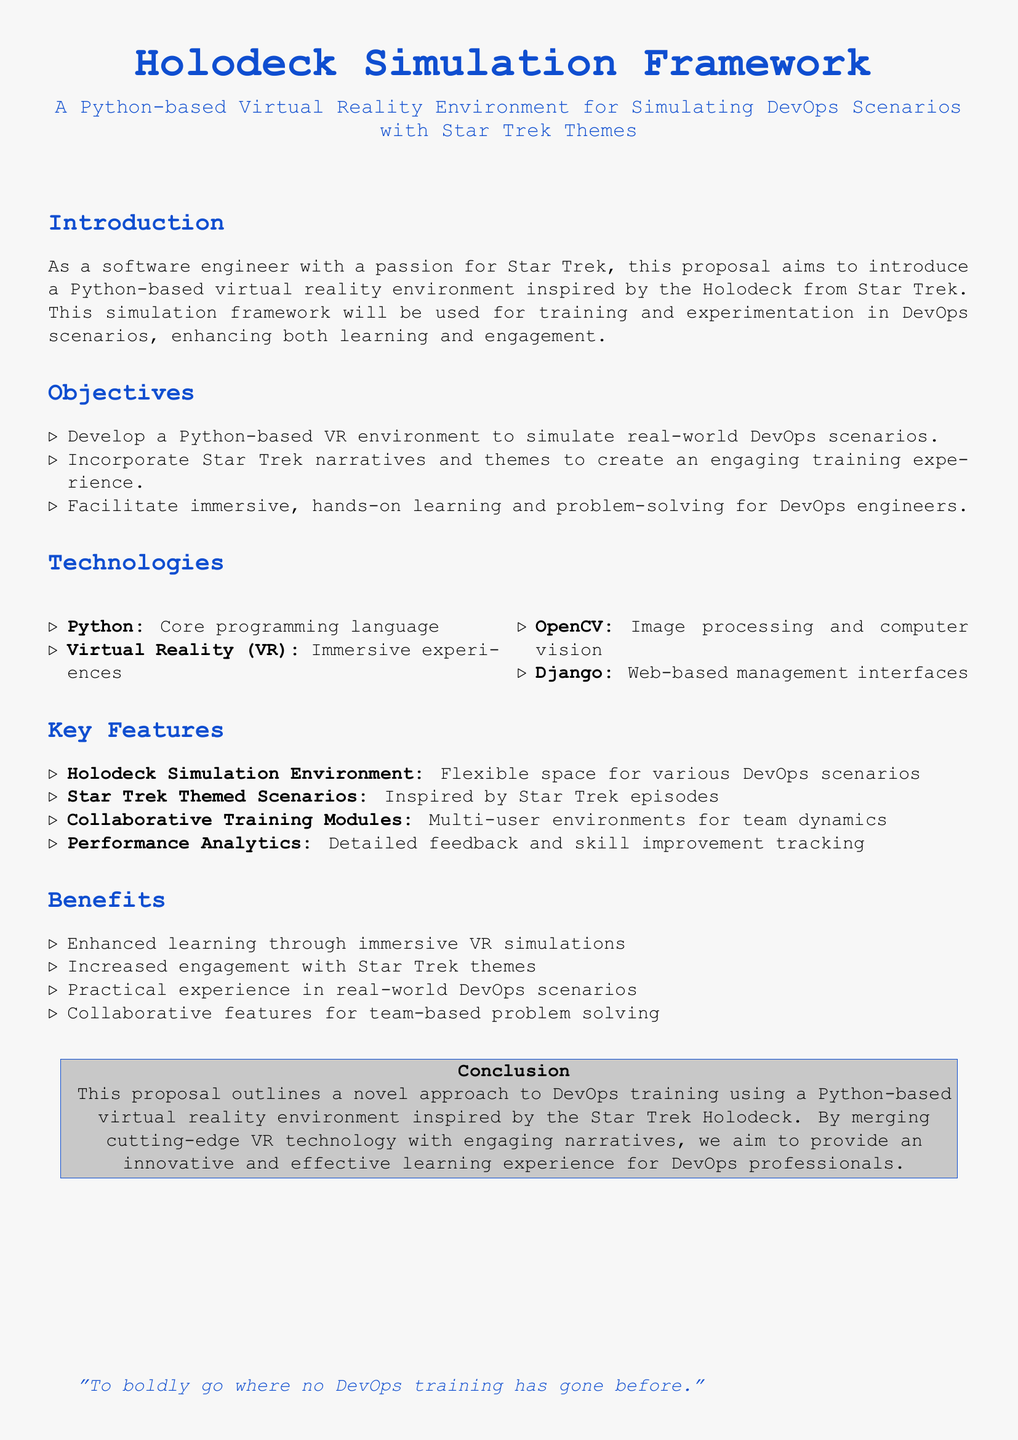What is the title of the proposal? The title is presented at the top of the document and identifies the main subject of the proposal.
Answer: Holodeck Simulation Framework What programming language is primarily used? The document lists Python as the core programming language.
Answer: Python What is one of the technologies mentioned? The proposal includes several technologies, one of which is explicitly listed.
Answer: OpenCV What type of training experience is proposed? The document describes the experience intended for the users, focusing on immersive learning.
Answer: immersive VR simulations Name one key feature of the project. The proposal outlines several features; one example is highlighted in the key features section.
Answer: Performance Analytics What is the purpose of the Holodeck Simulation Framework? The purpose is explicitly stated in the introduction and objectives sections of the document.
Answer: Simulating DevOps scenarios What color theme is used for the document? The document uses specific colors throughout; one main color is highlighted.
Answer: startrekblue What quote is included in the conclusion? A quote related to the purpose of the project is provided at the end of the document.
Answer: To boldly go where no DevOps training has gone before 